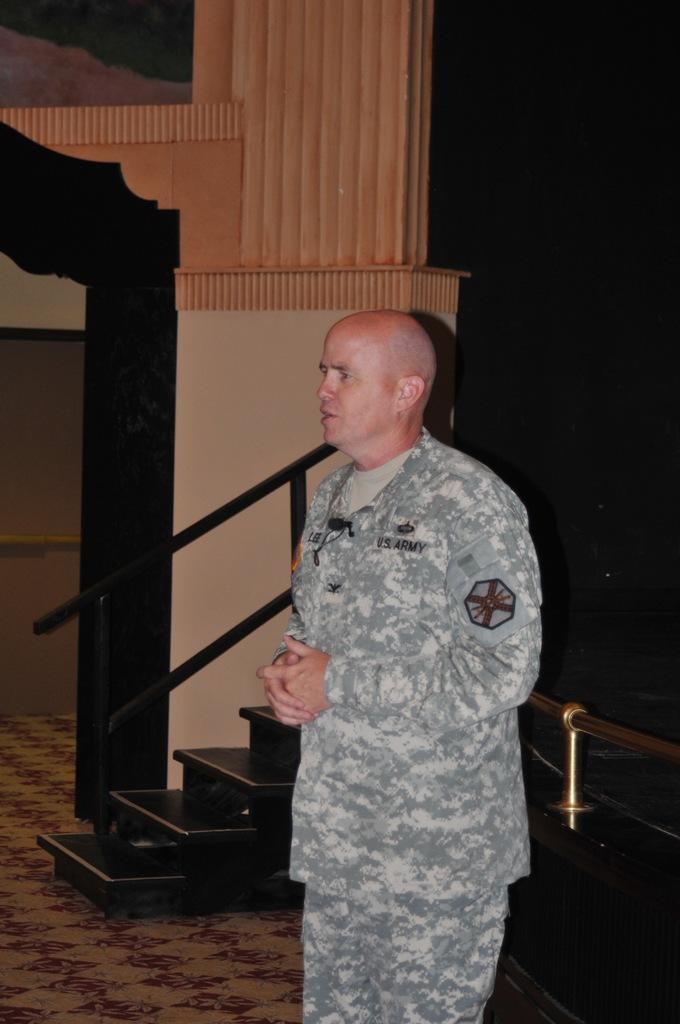How would you summarize this image in a sentence or two? In the middle of the image we can see a man, he is standing, behind him we can find few metal rods. 